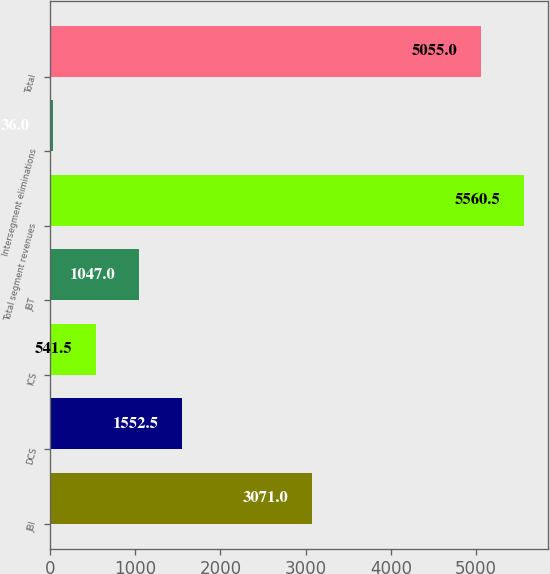Convert chart. <chart><loc_0><loc_0><loc_500><loc_500><bar_chart><fcel>JBI<fcel>DCS<fcel>ICS<fcel>JBT<fcel>Total segment revenues<fcel>Intersegment eliminations<fcel>Total<nl><fcel>3071<fcel>1552.5<fcel>541.5<fcel>1047<fcel>5560.5<fcel>36<fcel>5055<nl></chart> 